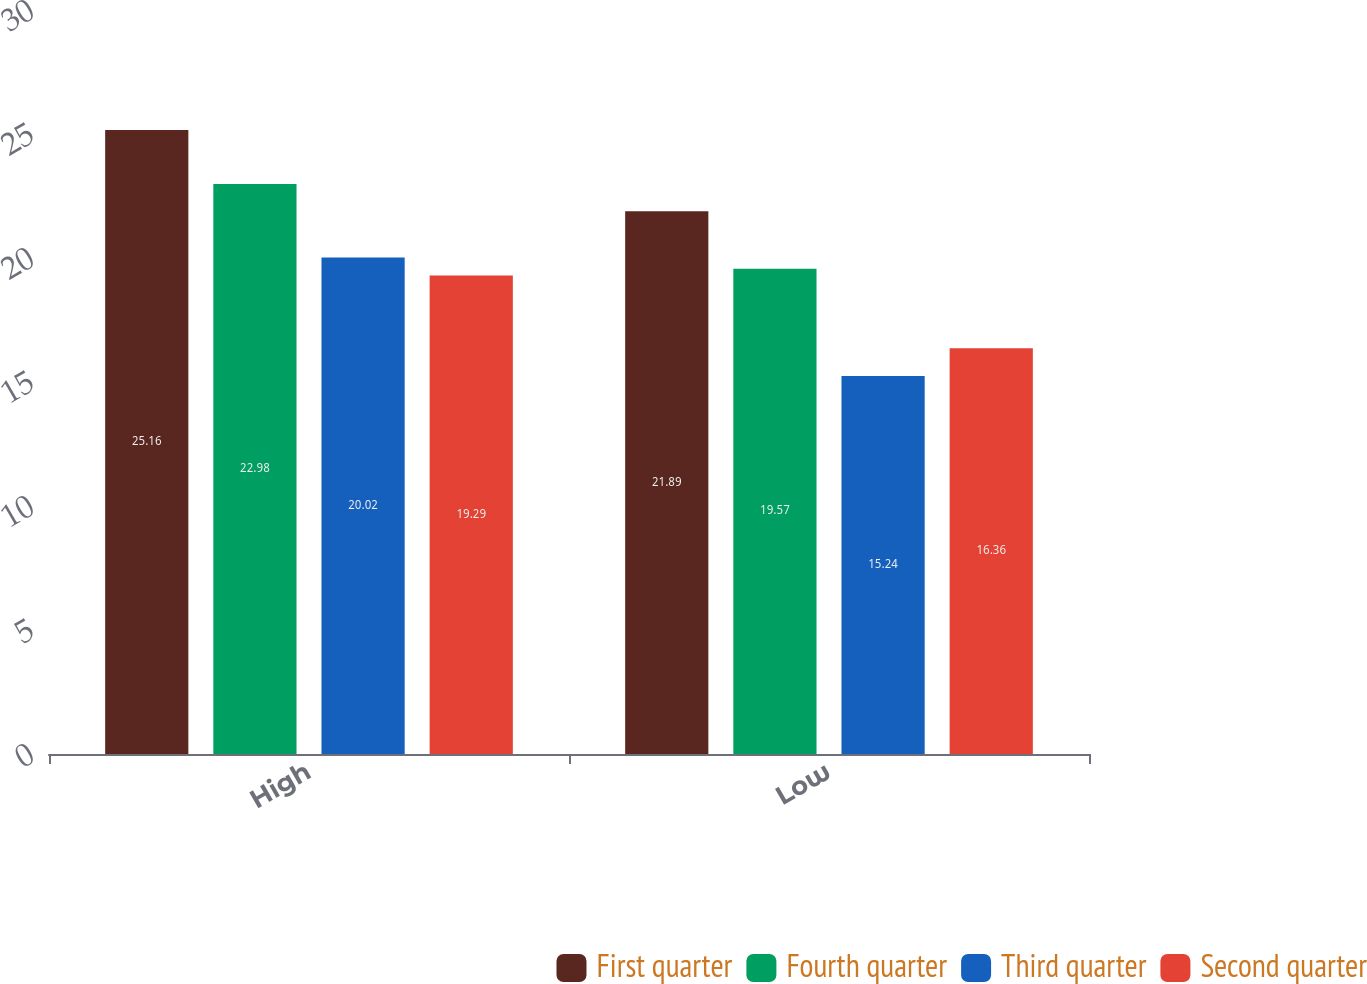Convert chart to OTSL. <chart><loc_0><loc_0><loc_500><loc_500><stacked_bar_chart><ecel><fcel>High<fcel>Low<nl><fcel>First quarter<fcel>25.16<fcel>21.89<nl><fcel>Fourth quarter<fcel>22.98<fcel>19.57<nl><fcel>Third quarter<fcel>20.02<fcel>15.24<nl><fcel>Second quarter<fcel>19.29<fcel>16.36<nl></chart> 